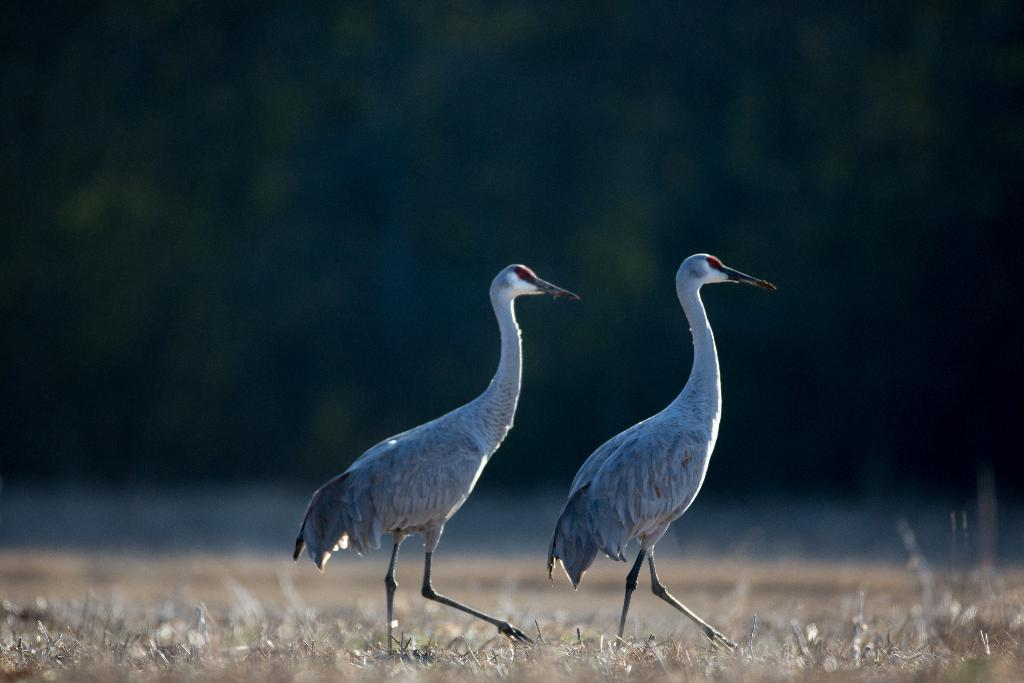How many cranes are present in the image? There are 2 cranes in the image. What colors can be seen on the cranes? The cranes are white and grey in color. What type of vegetation is visible in the image? There is grass visible in the image. Can you describe the background of the image? The background is blurred. What type of thread is being used to sew the pin onto the lamp in the image? There is no pin, thread, or lamp present in the image; it features 2 cranes and grass. 